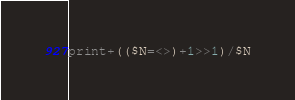<code> <loc_0><loc_0><loc_500><loc_500><_Perl_>print+(($N=<>)+1>>1)/$N</code> 